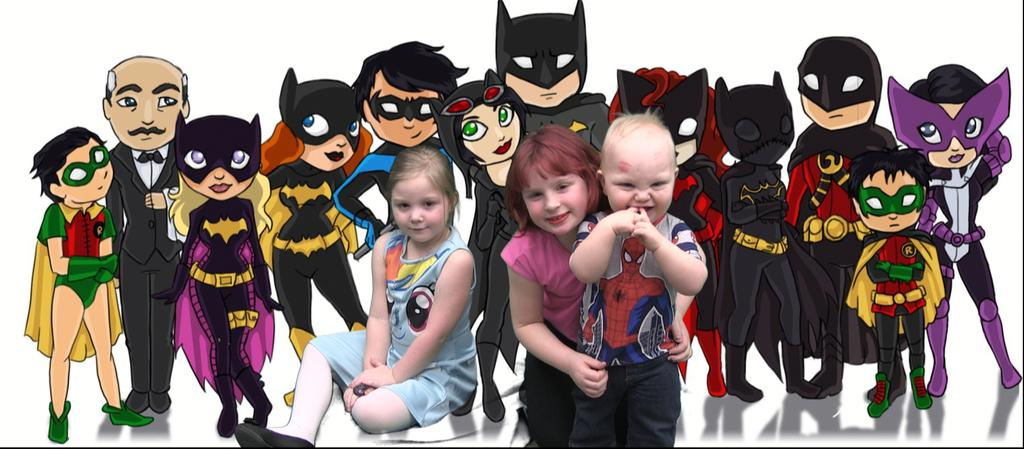What type of image is this? The image is an edited picture. What can be seen in the background of the image? There is a cartoon in the background of the image. How many people are in the image? There are two girls and a boy in the image. What are the girls and the boy doing in the image? The girls and the boy are posing to the camera, as mentioned in the facts. We start by identifying the nature of the image, which is an edited picture. Then, we describe the background, which features a cartoon. Next, we count the number of people in the image and identify their genders. Finally, we observe their actions, which are posing for the camera. Absurd Question/Answer: What type of toy can be seen in the jar in the image? There is no jar or toy present in the image. What type of example can be seen in the jar in the image? There is no jar or example present in the image. 